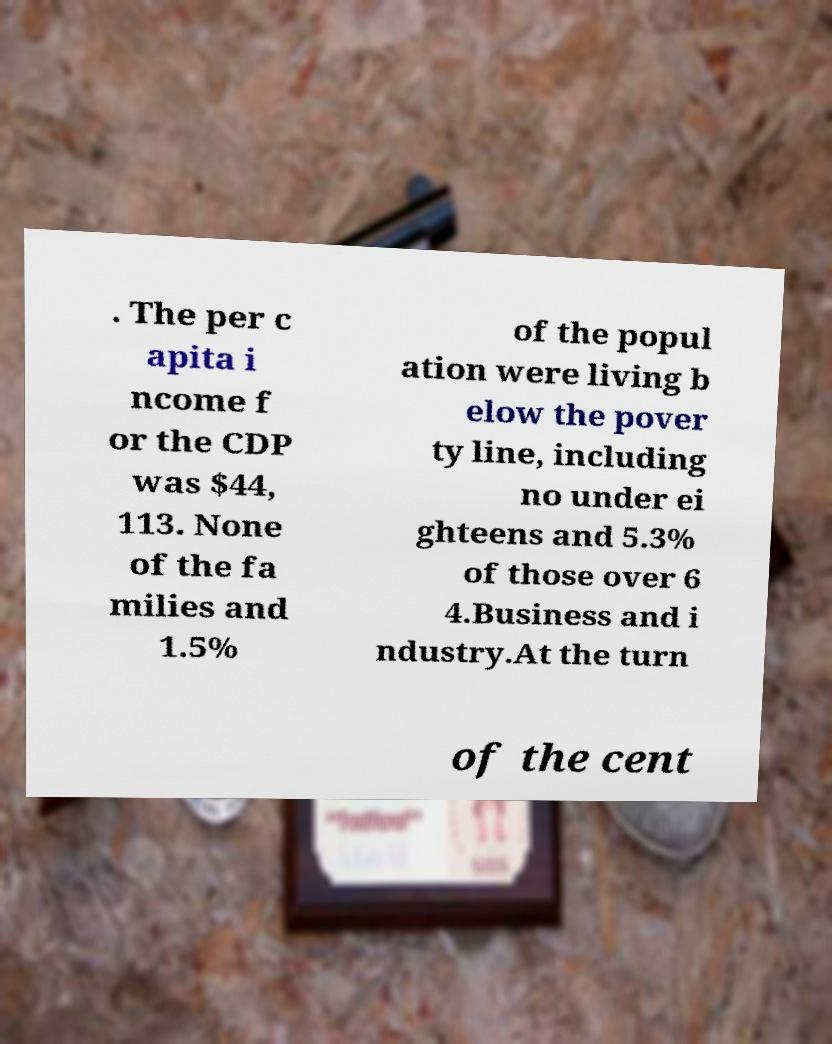Could you extract and type out the text from this image? . The per c apita i ncome f or the CDP was $44, 113. None of the fa milies and 1.5% of the popul ation were living b elow the pover ty line, including no under ei ghteens and 5.3% of those over 6 4.Business and i ndustry.At the turn of the cent 